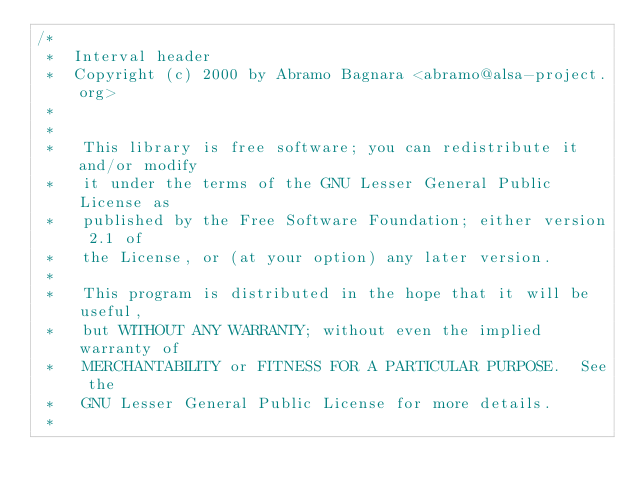<code> <loc_0><loc_0><loc_500><loc_500><_C_>/*
 *  Interval header
 *  Copyright (c) 2000 by Abramo Bagnara <abramo@alsa-project.org>
 *
 *
 *   This library is free software; you can redistribute it and/or modify
 *   it under the terms of the GNU Lesser General Public License as
 *   published by the Free Software Foundation; either version 2.1 of
 *   the License, or (at your option) any later version.
 *
 *   This program is distributed in the hope that it will be useful,
 *   but WITHOUT ANY WARRANTY; without even the implied warranty of
 *   MERCHANTABILITY or FITNESS FOR A PARTICULAR PURPOSE.  See the
 *   GNU Lesser General Public License for more details.
 *</code> 